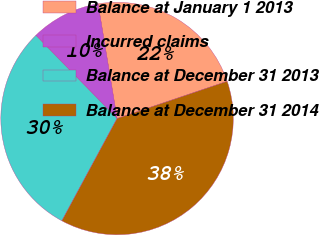<chart> <loc_0><loc_0><loc_500><loc_500><pie_chart><fcel>Balance at January 1 2013<fcel>Incurred claims<fcel>Balance at December 31 2013<fcel>Balance at December 31 2014<nl><fcel>22.43%<fcel>9.7%<fcel>29.81%<fcel>38.06%<nl></chart> 